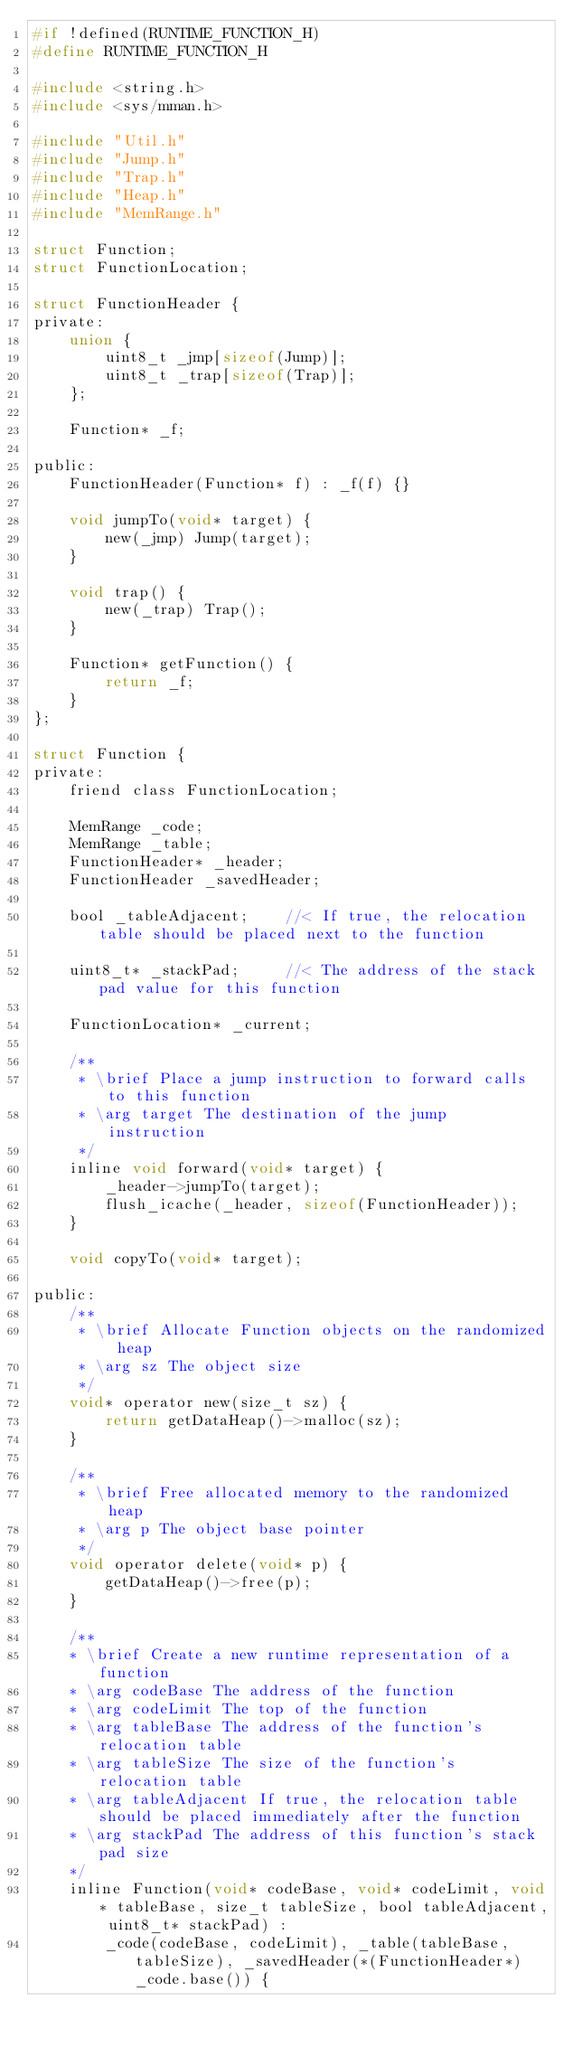<code> <loc_0><loc_0><loc_500><loc_500><_C_>#if !defined(RUNTIME_FUNCTION_H)
#define RUNTIME_FUNCTION_H

#include <string.h>
#include <sys/mman.h>

#include "Util.h"
#include "Jump.h"
#include "Trap.h"
#include "Heap.h"
#include "MemRange.h"

struct Function;
struct FunctionLocation;

struct FunctionHeader {
private:
    union {
        uint8_t _jmp[sizeof(Jump)];
        uint8_t _trap[sizeof(Trap)];
    };
    
    Function* _f;
    
public:
    FunctionHeader(Function* f) : _f(f) {}
    
    void jumpTo(void* target) {
        new(_jmp) Jump(target);
    }
    
    void trap() {
        new(_trap) Trap();
    }
    
    Function* getFunction() {
        return _f;
    }
};

struct Function {
private:
    friend class FunctionLocation;
    
    MemRange _code;
    MemRange _table;
    FunctionHeader* _header;
    FunctionHeader _savedHeader;
    
    bool _tableAdjacent;    //< If true, the relocation table should be placed next to the function
    
    uint8_t* _stackPad;		//< The address of the stack pad value for this function
    
    FunctionLocation* _current;
    
    /**
     * \brief Place a jump instruction to forward calls to this function
     * \arg target The destination of the jump instruction
     */
    inline void forward(void* target) {
        _header->jumpTo(target);
        flush_icache(_header, sizeof(FunctionHeader));
    }
    
    void copyTo(void* target);
    
public:
    /**
     * \brief Allocate Function objects on the randomized heap
     * \arg sz The object size
     */
    void* operator new(size_t sz) {
        return getDataHeap()->malloc(sz);
    }
    
    /**
     * \brief Free allocated memory to the randomized heap
     * \arg p The object base pointer
     */
    void operator delete(void* p) {
        getDataHeap()->free(p);
    }
    
    /**
    * \brief Create a new runtime representation of a function
    * \arg codeBase The address of the function
    * \arg codeLimit The top of the function
    * \arg tableBase The address of the function's relocation table
    * \arg tableSize The size of the function's relocation table
    * \arg tableAdjacent If true, the relocation table should be placed immediately after the function
	* \arg stackPad The address of this function's stack pad size
    */
    inline Function(void* codeBase, void* codeLimit, void* tableBase, size_t tableSize, bool tableAdjacent, uint8_t* stackPad) :
        _code(codeBase, codeLimit), _table(tableBase, tableSize), _savedHeader(*(FunctionHeader*)_code.base()) {
        </code> 